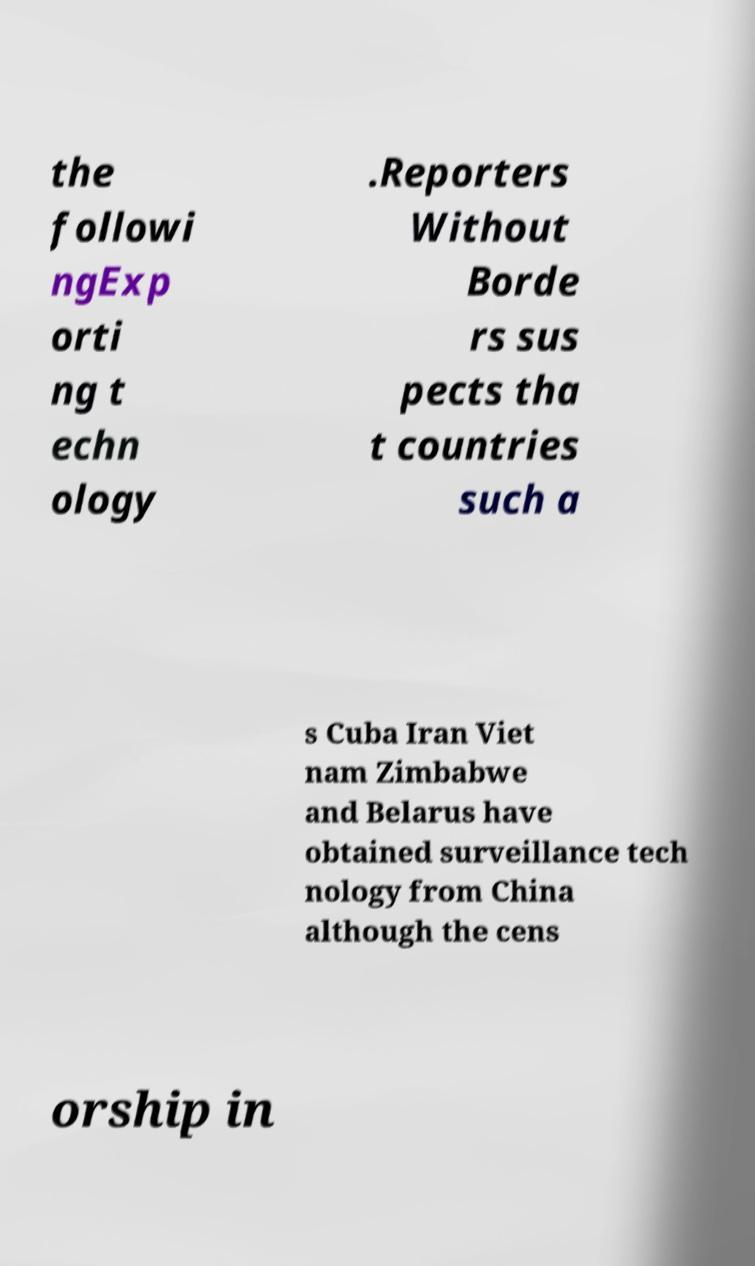Please identify and transcribe the text found in this image. the followi ngExp orti ng t echn ology .Reporters Without Borde rs sus pects tha t countries such a s Cuba Iran Viet nam Zimbabwe and Belarus have obtained surveillance tech nology from China although the cens orship in 